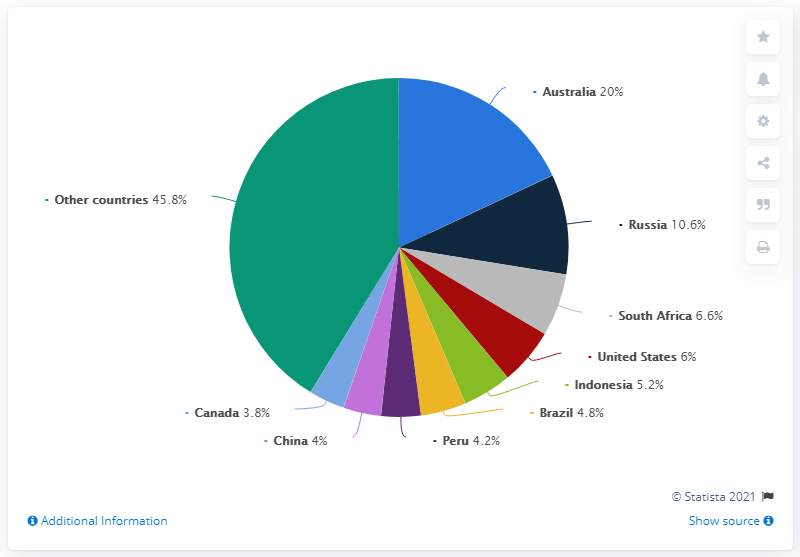Indicate a few pertinent items in this graphic. The combined value of Australia and Russia in percentage terms is 30.6%. There are 10 colors in the pie chart. 